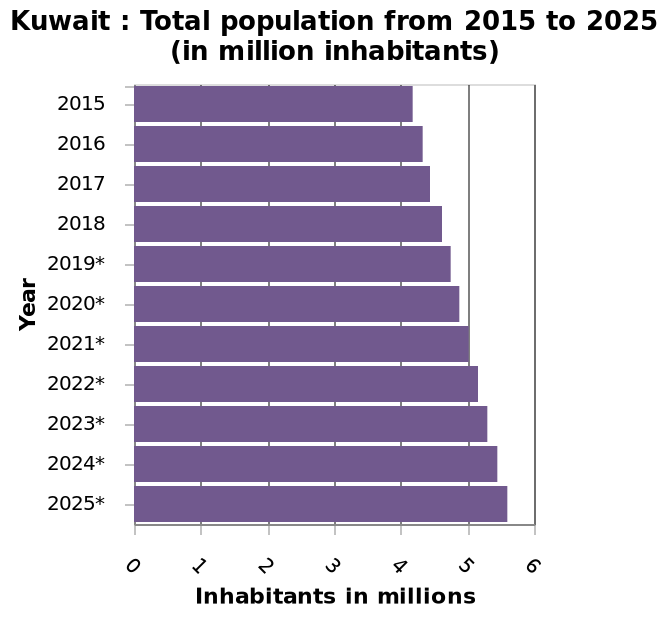<image>
Offer a thorough analysis of the image. Over the past 10 years Kuwait has had a steady increase in population. How much has the population of Kuwait increased from 2015 to 2018? The population of Kuwait has increased by approximately 500,000 inhabitants from 2015 to 2018. 